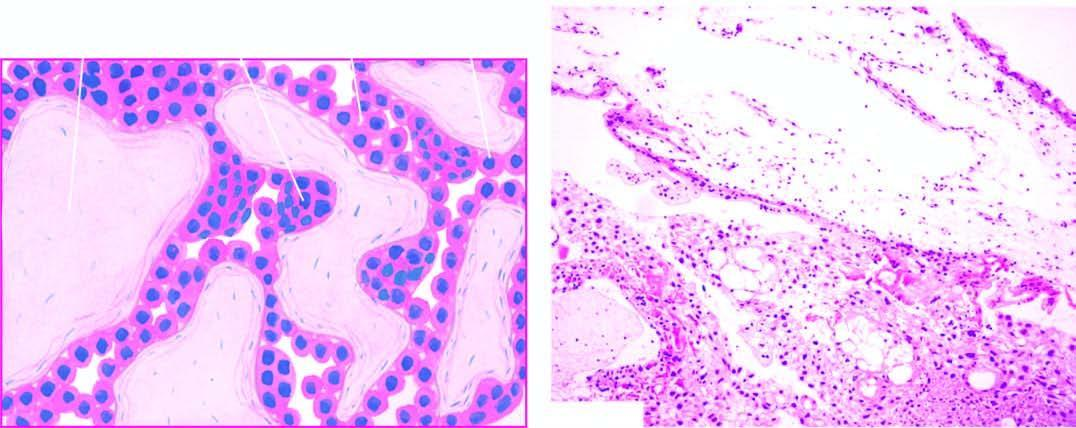what is hydatidiform mole characterised by?
Answer the question using a single word or phrase. Hydropic and avascular enlarged villi 